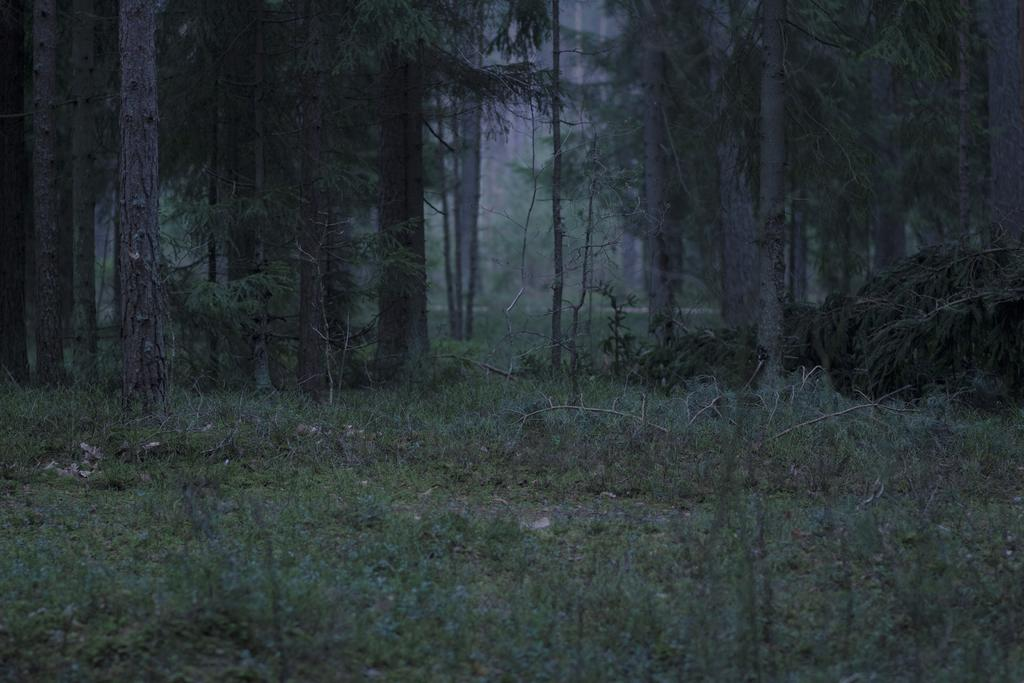What type of vegetation is predominant in the image? There are many trees in the image. What is the color of the grass at the bottom of the image? The grass at the bottom of the image is green. What type of environment does the image depict? The image appears to depict a forest. What type of brake system can be seen on the trees in the image? There is no brake system present on the trees in the image; it is a forest scene with trees and grass. 